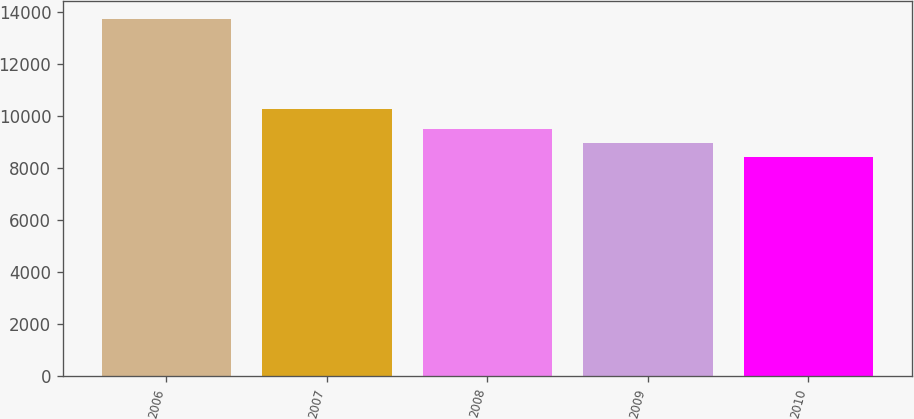Convert chart to OTSL. <chart><loc_0><loc_0><loc_500><loc_500><bar_chart><fcel>2006<fcel>2007<fcel>2008<fcel>2009<fcel>2010<nl><fcel>13715<fcel>10252<fcel>9471.8<fcel>8941.4<fcel>8411<nl></chart> 